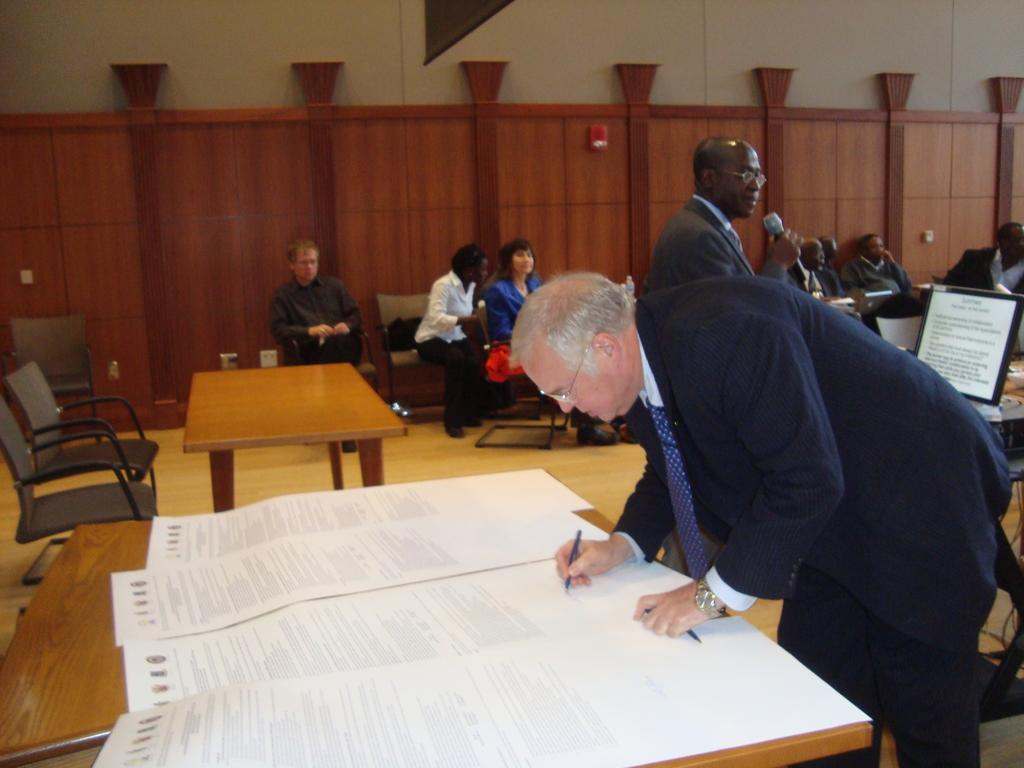What is the person in the image wearing? The person is wearing a suit in the image. What is the person doing while wearing the suit? The person is writing on a paper. Where is the paper placed? The paper is placed on a table. Can you describe the people behind the person? There is a group of people behind the person. What type of farm animals can be seen in the image? There are no farm animals present in the image. Is the tent visible in the image? There is no tent present in the image. 